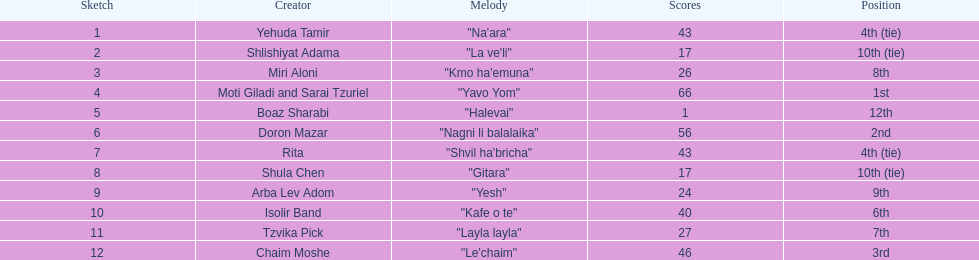What is the total amount of ties in this competition? 2. 